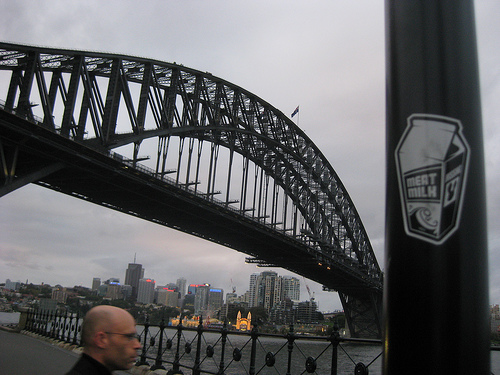<image>
Can you confirm if the sticker is on the bridge? No. The sticker is not positioned on the bridge. They may be near each other, but the sticker is not supported by or resting on top of the bridge. Where is the man in relation to the bridge? Is it under the bridge? Yes. The man is positioned underneath the bridge, with the bridge above it in the vertical space. 